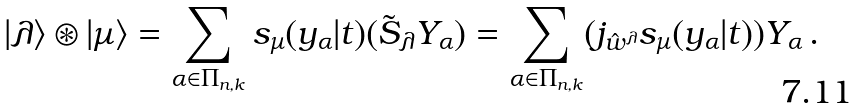<formula> <loc_0><loc_0><loc_500><loc_500>| \lambda \rangle \circledast | \mu \rangle = \sum _ { \alpha \in \Pi _ { n , k } } s _ { \mu } ( y _ { \alpha } | t ) ( \tilde { S } _ { \lambda } Y _ { \alpha } ) = \sum _ { \alpha \in \Pi _ { n , k } } ( j _ { \hat { w } ^ { \lambda } } s _ { \mu } ( y _ { \alpha } | t ) ) Y _ { \alpha } \, .</formula> 